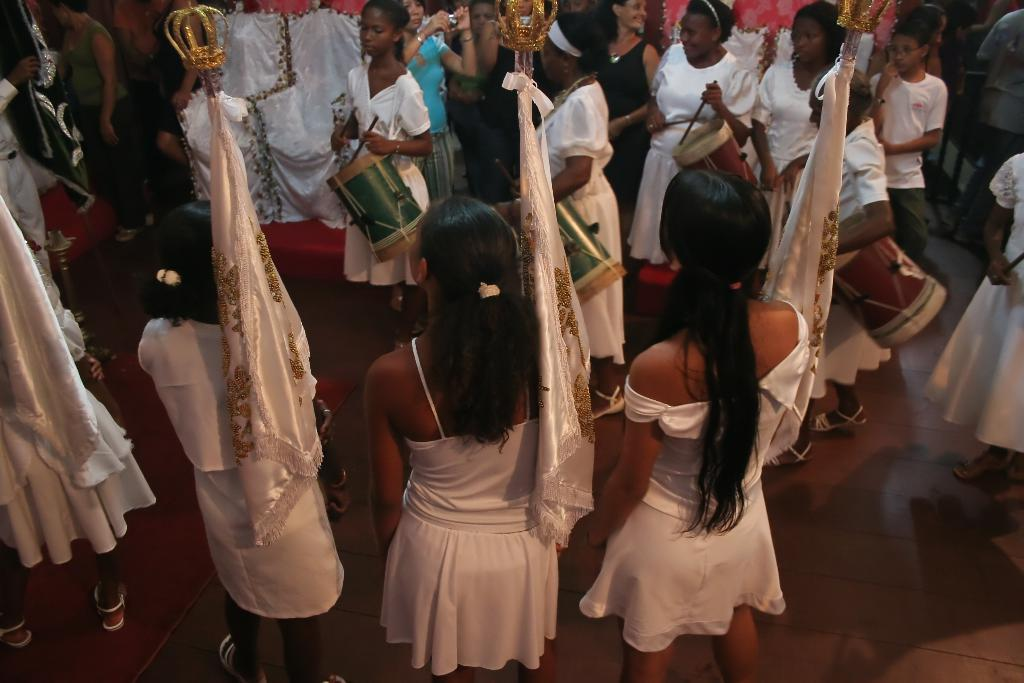Who is present in the image? There are women in the image. What are the women holding in the image? The women are holding flags. What other activity is happening in the image? There are people playing drums in the image. What type of rice is being served to the women in the image? There is no rice present in the image; the women are holding flags. What kind of hat is the woman wearing in the image? There is no hat mentioned or visible in the image; the women are holding flags. 